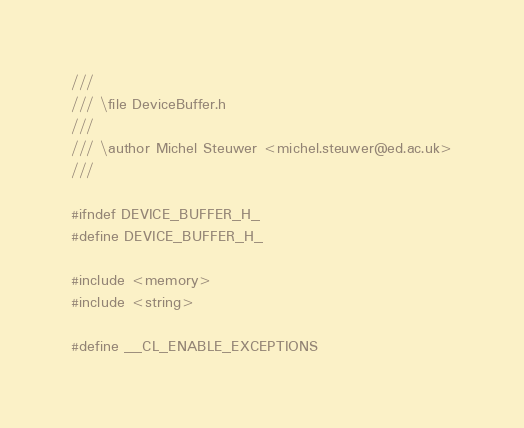Convert code to text. <code><loc_0><loc_0><loc_500><loc_500><_C_>///
/// \file DeviceBuffer.h
///
/// \author Michel Steuwer <michel.steuwer@ed.ac.uk>
///

#ifndef DEVICE_BUFFER_H_
#define DEVICE_BUFFER_H_

#include <memory>
#include <string>

#define __CL_ENABLE_EXCEPTIONS</code> 